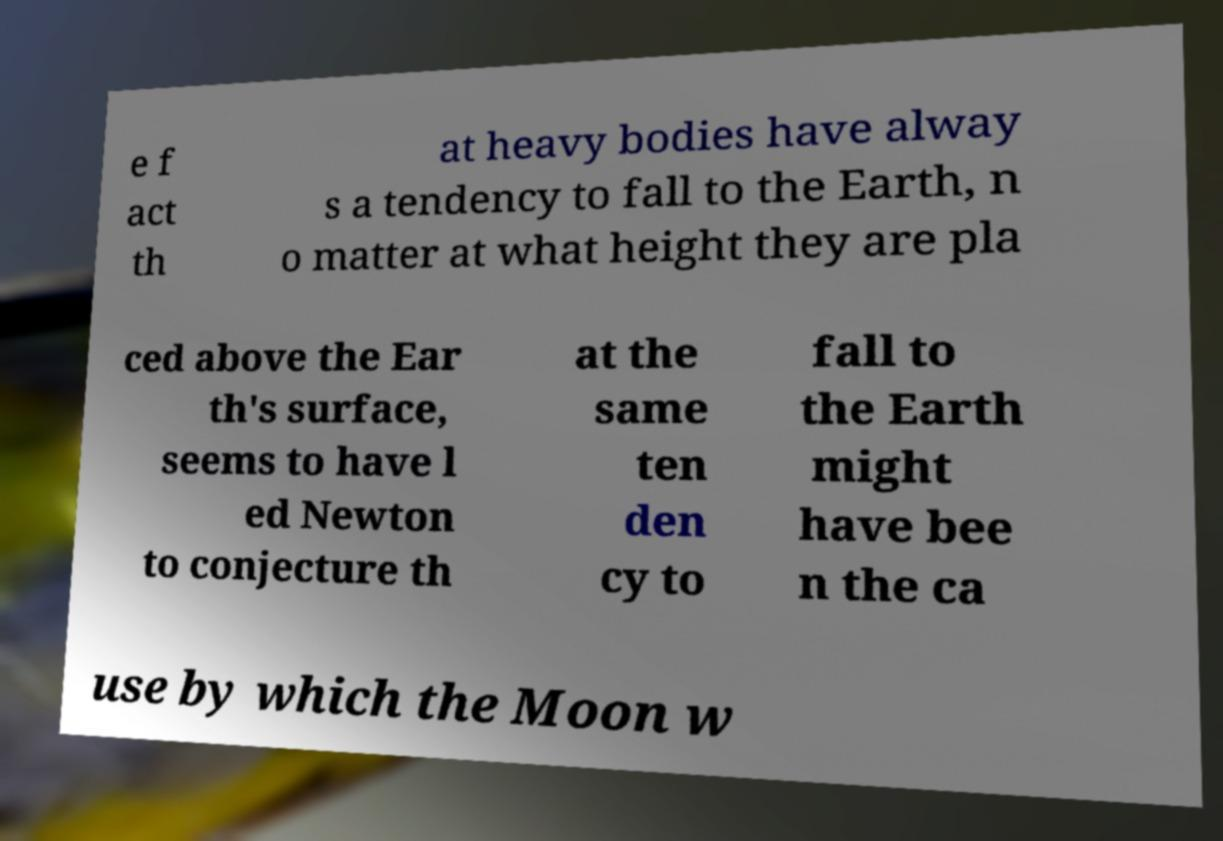Can you accurately transcribe the text from the provided image for me? e f act th at heavy bodies have alway s a tendency to fall to the Earth, n o matter at what height they are pla ced above the Ear th's surface, seems to have l ed Newton to conjecture th at the same ten den cy to fall to the Earth might have bee n the ca use by which the Moon w 